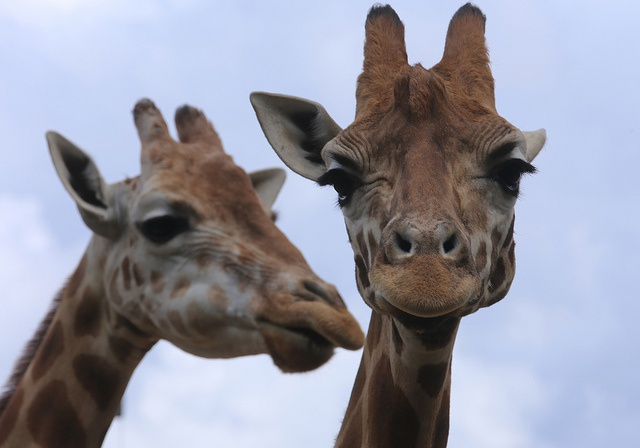Describe the objects in this image and their specific colors. I can see giraffe in lavender, gray, black, and maroon tones and giraffe in lavender, gray, black, and maroon tones in this image. 